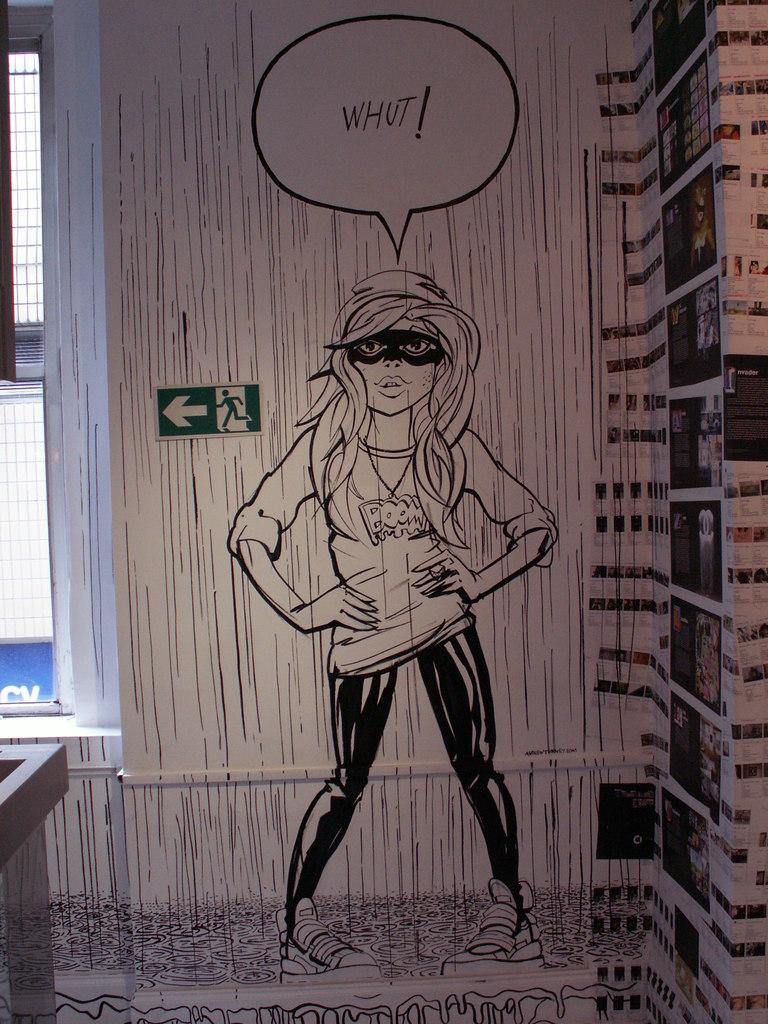What is on the wall in the image? There is a painting of a woman on the wall. Are there any other items on the wall besides the painting? Yes, there are photographs on the right side of the wall. What can be seen on the left side of the image? There are windows on the left side of the image. What type of gold object is hanging from the painting in the image? There is no gold object hanging from the painting in the image. Who is the expert in the image? There is no expert depicted in the image. 